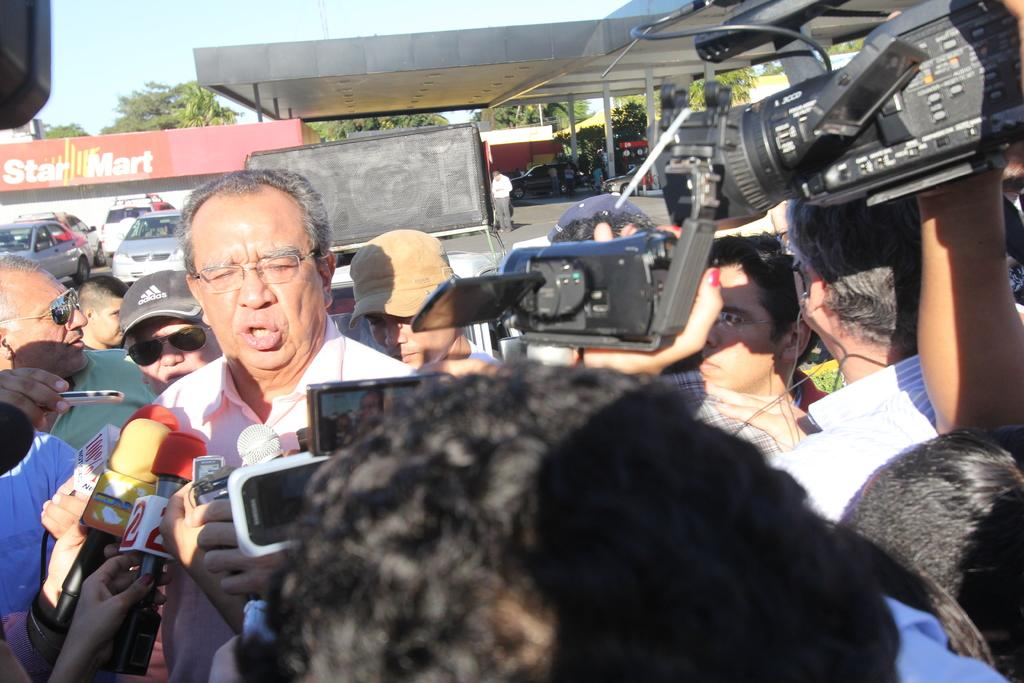How many people are in the group visible in the image? There is a group of people in the image, but the exact number is not specified. What objects are present in the image that are used for capturing images? Cameras are present in the image. What type of communication devices can be seen in the image? Mobiles are visible in the image. What devices are used for amplifying sound in the image? Microphones (mics) are in the image. What type of headwear is present in the image? Caps are present in the image. What type of eye protection is visible in the image? Goggles are visible in the image. What type of transportation is in the image? Vehicles are in the image. What type of structures are present in the image? Sheds are present in the image. What type of natural vegetation is in the image? Trees are in the image. What unspecified objects are present in the image? There are some unspecified objects in the image. What can be seen in the background of the image? The sky is visible in the background of the image. What type of wine is being served in the image? There is no wine present in the image. What type of quiver is visible in the image? There is no quiver present in the image. 